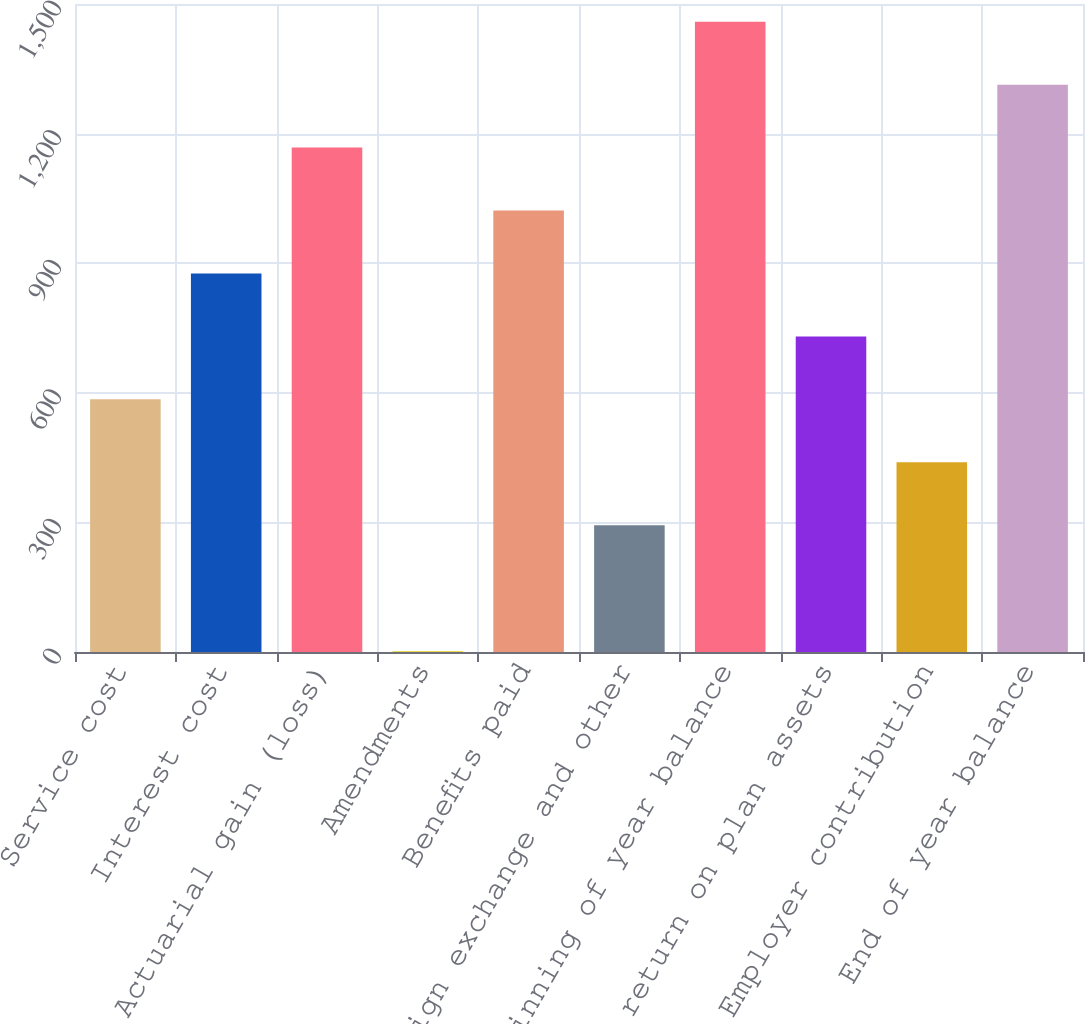Convert chart to OTSL. <chart><loc_0><loc_0><loc_500><loc_500><bar_chart><fcel>Service cost<fcel>Interest cost<fcel>Actuarial gain (loss)<fcel>Amendments<fcel>Benefits paid<fcel>Foreign exchange and other<fcel>Beginning of year balance<fcel>Actual return on plan assets<fcel>Employer contribution<fcel>End of year balance<nl><fcel>584.8<fcel>876.2<fcel>1167.6<fcel>2<fcel>1021.9<fcel>293.4<fcel>1459<fcel>730.5<fcel>439.1<fcel>1313.3<nl></chart> 